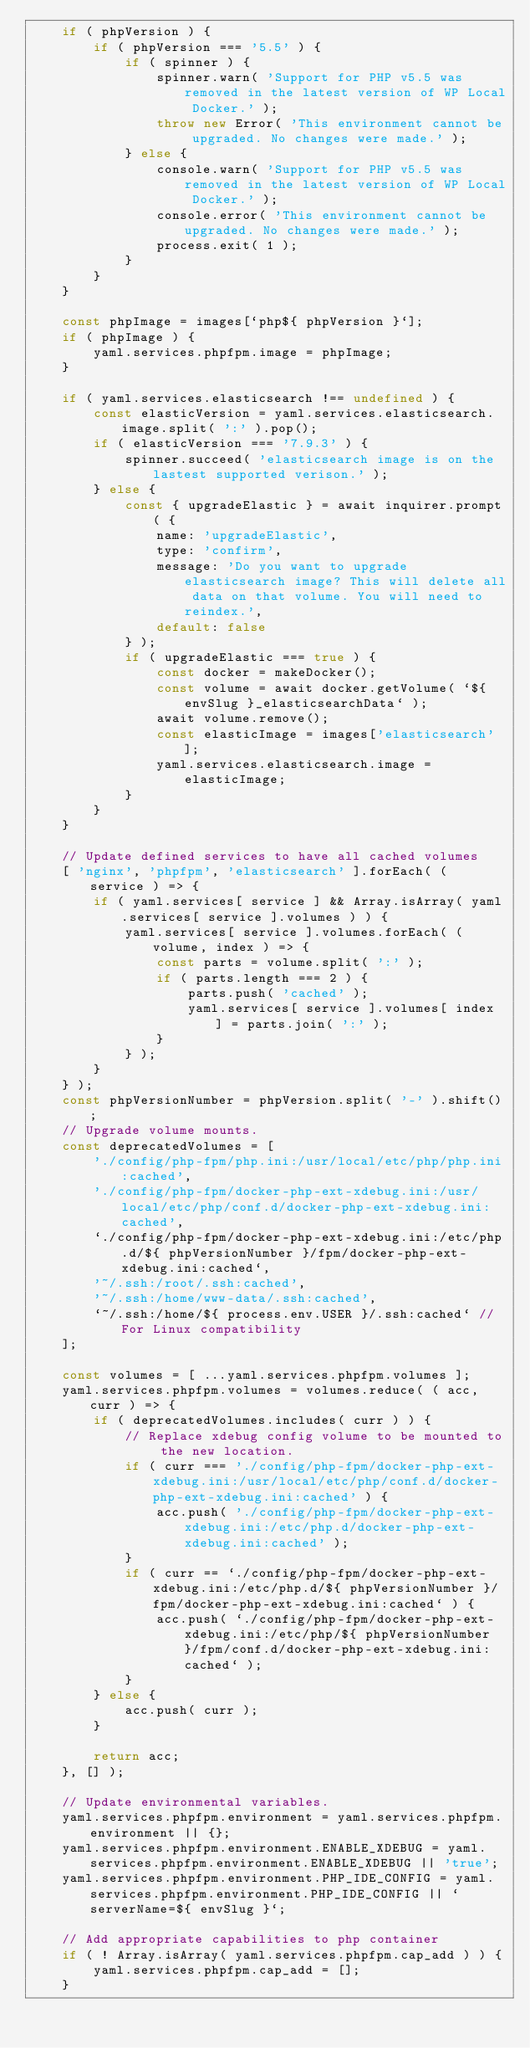Convert code to text. <code><loc_0><loc_0><loc_500><loc_500><_JavaScript_>	if ( phpVersion ) {
		if ( phpVersion === '5.5' ) {
			if ( spinner ) {
				spinner.warn( 'Support for PHP v5.5 was removed in the latest version of WP Local Docker.' );
				throw new Error( 'This environment cannot be upgraded. No changes were made.' );
			} else {
				console.warn( 'Support for PHP v5.5 was removed in the latest version of WP Local Docker.' );
				console.error( 'This environment cannot be upgraded. No changes were made.' );
				process.exit( 1 );
			}
		}
	}

	const phpImage = images[`php${ phpVersion }`];
	if ( phpImage ) {
		yaml.services.phpfpm.image = phpImage;
	}

	if ( yaml.services.elasticsearch !== undefined ) {
		const elasticVersion = yaml.services.elasticsearch.image.split( ':' ).pop();
		if ( elasticVersion === '7.9.3' ) {
			spinner.succeed( 'elasticsearch image is on the lastest supported verison.' );
		} else {
			const { upgradeElastic } = await inquirer.prompt( {
				name: 'upgradeElastic',
				type: 'confirm',
				message: 'Do you want to upgrade elasticsearch image? This will delete all data on that volume. You will need to reindex.',
				default: false
			} );
			if ( upgradeElastic === true ) {
				const docker = makeDocker();
				const volume = await docker.getVolume( `${ envSlug }_elasticsearchData` );
				await volume.remove();
				const elasticImage = images['elasticsearch'];
				yaml.services.elasticsearch.image = elasticImage;
			}
		}
	}

	// Update defined services to have all cached volumes
	[ 'nginx', 'phpfpm', 'elasticsearch' ].forEach( ( service ) => {
		if ( yaml.services[ service ] && Array.isArray( yaml.services[ service ].volumes ) ) {
			yaml.services[ service ].volumes.forEach( ( volume, index ) => {
				const parts = volume.split( ':' );
				if ( parts.length === 2 ) {
					parts.push( 'cached' );
					yaml.services[ service ].volumes[ index ] = parts.join( ':' );
				}
			} );
		}
	} );
	const phpVersionNumber = phpVersion.split( '-' ).shift();
	// Upgrade volume mounts.
	const deprecatedVolumes = [
		'./config/php-fpm/php.ini:/usr/local/etc/php/php.ini:cached',
		'./config/php-fpm/docker-php-ext-xdebug.ini:/usr/local/etc/php/conf.d/docker-php-ext-xdebug.ini:cached',
		`./config/php-fpm/docker-php-ext-xdebug.ini:/etc/php.d/${ phpVersionNumber }/fpm/docker-php-ext-xdebug.ini:cached`,
		'~/.ssh:/root/.ssh:cached',
		'~/.ssh:/home/www-data/.ssh:cached',
		`~/.ssh:/home/${ process.env.USER }/.ssh:cached` // For Linux compatibility
	];

	const volumes = [ ...yaml.services.phpfpm.volumes ];
	yaml.services.phpfpm.volumes = volumes.reduce( ( acc, curr ) => {
		if ( deprecatedVolumes.includes( curr ) ) {
			// Replace xdebug config volume to be mounted to the new location.
			if ( curr === './config/php-fpm/docker-php-ext-xdebug.ini:/usr/local/etc/php/conf.d/docker-php-ext-xdebug.ini:cached' ) {
				acc.push( './config/php-fpm/docker-php-ext-xdebug.ini:/etc/php.d/docker-php-ext-xdebug.ini:cached' );
			}
			if ( curr == `./config/php-fpm/docker-php-ext-xdebug.ini:/etc/php.d/${ phpVersionNumber }/fpm/docker-php-ext-xdebug.ini:cached` ) {
				acc.push( `./config/php-fpm/docker-php-ext-xdebug.ini:/etc/php/${ phpVersionNumber }/fpm/conf.d/docker-php-ext-xdebug.ini:cached` );
			}
		} else {
			acc.push( curr );
		}

		return acc;
	}, [] );

	// Update environmental variables.
	yaml.services.phpfpm.environment = yaml.services.phpfpm.environment || {};
	yaml.services.phpfpm.environment.ENABLE_XDEBUG = yaml.services.phpfpm.environment.ENABLE_XDEBUG || 'true';
	yaml.services.phpfpm.environment.PHP_IDE_CONFIG = yaml.services.phpfpm.environment.PHP_IDE_CONFIG || `serverName=${ envSlug }`;

	// Add appropriate capabilities to php container
	if ( ! Array.isArray( yaml.services.phpfpm.cap_add ) ) {
		yaml.services.phpfpm.cap_add = [];
	}</code> 